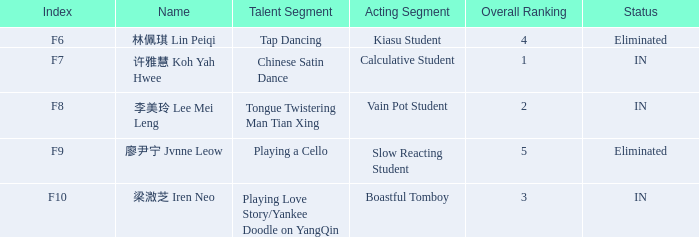For all events with index f10, what is the sum of the overall rankings? 3.0. 